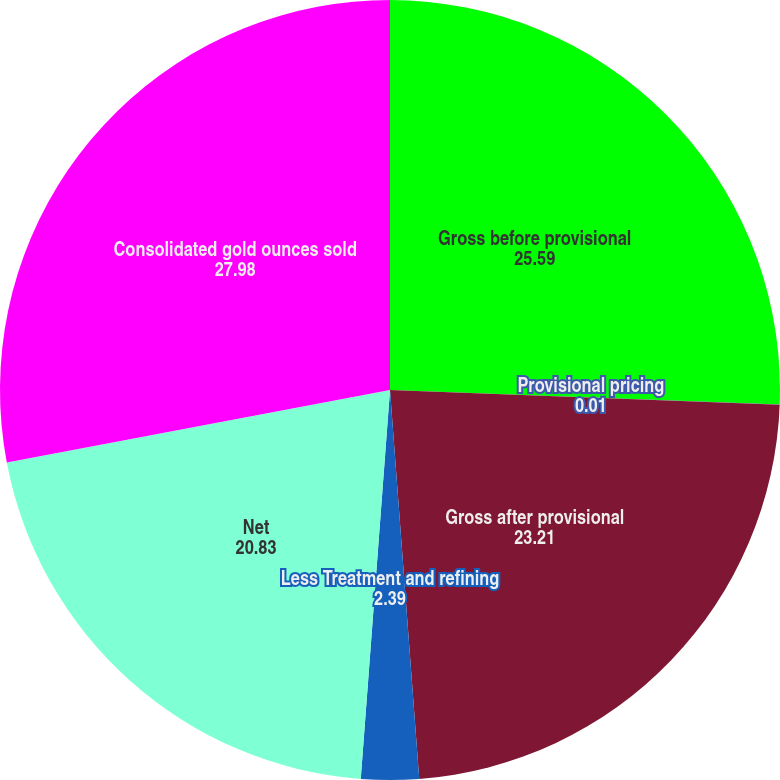Convert chart to OTSL. <chart><loc_0><loc_0><loc_500><loc_500><pie_chart><fcel>Gross before provisional<fcel>Provisional pricing<fcel>Gross after provisional<fcel>Less Treatment and refining<fcel>Net<fcel>Consolidated gold ounces sold<nl><fcel>25.59%<fcel>0.01%<fcel>23.21%<fcel>2.39%<fcel>20.83%<fcel>27.98%<nl></chart> 